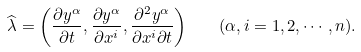<formula> <loc_0><loc_0><loc_500><loc_500>\widehat { \lambda } = \left ( \frac { \partial y ^ { \alpha } } { \partial t } , \frac { \partial y ^ { \alpha } } { \partial x ^ { i } } , \frac { \partial ^ { 2 } y ^ { \alpha } } { \partial x ^ { i } \partial t } \right ) \quad ( \alpha , i = 1 , 2 , \cdots , n ) .</formula> 